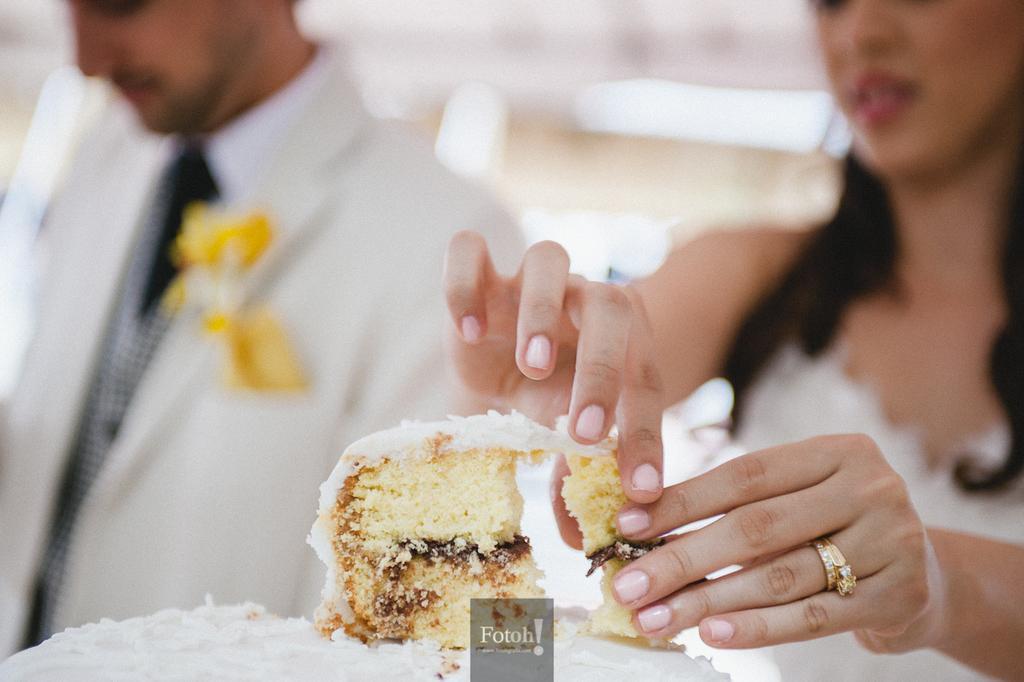Could you give a brief overview of what you see in this image? In this image we can see a piece of cake at the bottom of the image. A lady is holding the piece of cake. She is wearing a ring. Also there is another person. In the background it is looking blur. 